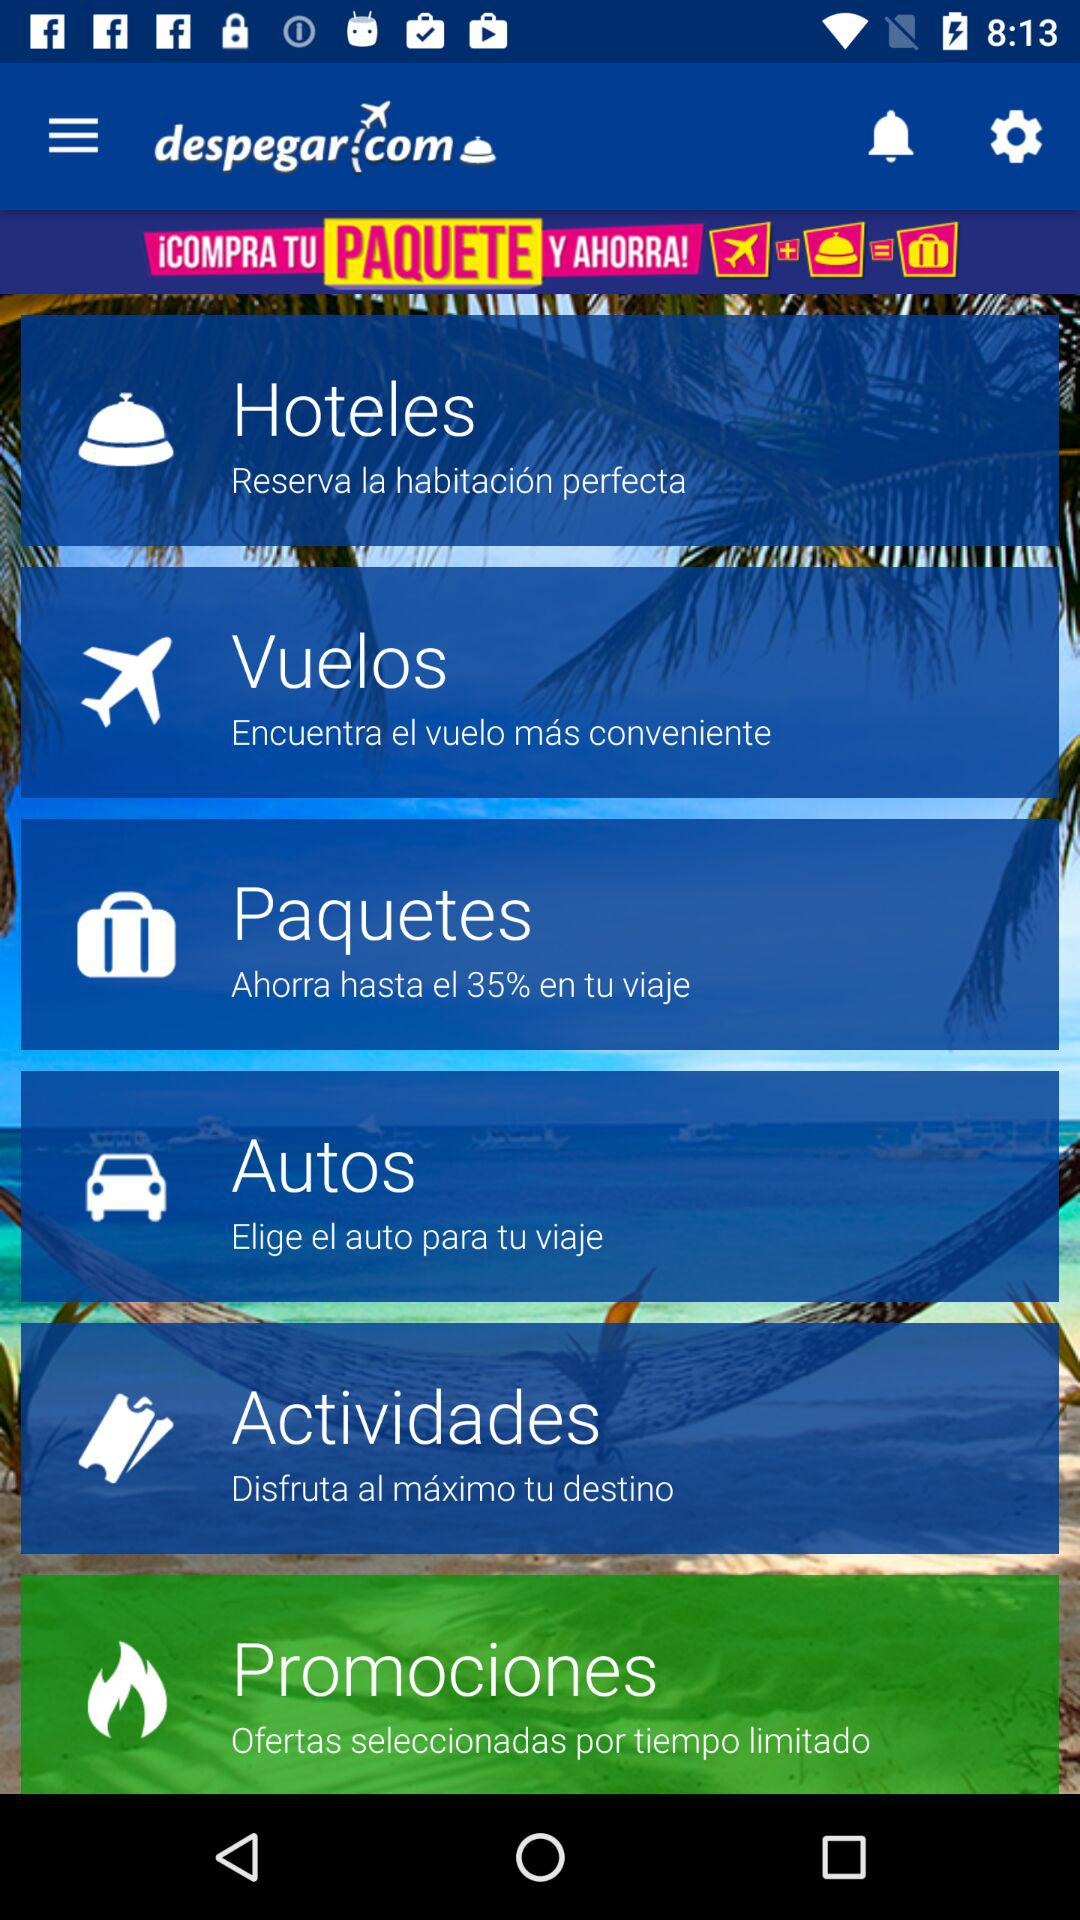What is the name of the application? The name of the application is "despegar". 